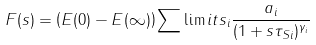<formula> <loc_0><loc_0><loc_500><loc_500>F ( s ) = \left ( E ( 0 ) - E ( \infty ) \right ) \sum \lim i t s _ { i } \frac { a _ { i } } { ( 1 + s \tau _ { S i } ) ^ { \gamma _ { i } } }</formula> 